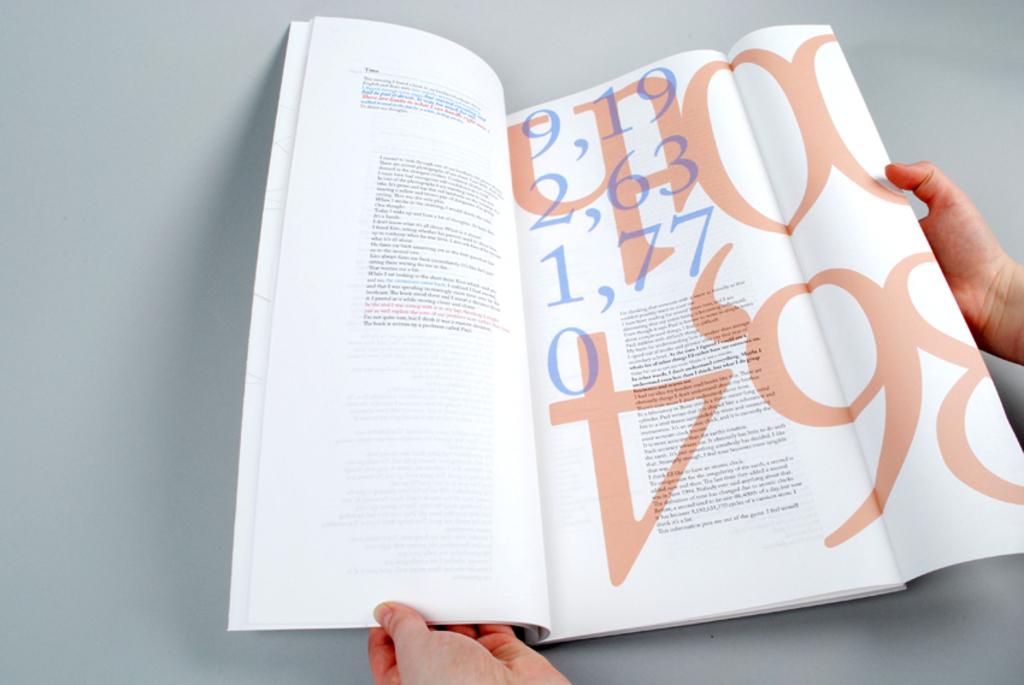What numbers are in the magazine?
Give a very brief answer. 9,19 2,63 1,77 0. 